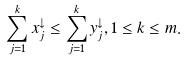Convert formula to latex. <formula><loc_0><loc_0><loc_500><loc_500>\sum _ { j = 1 } ^ { k } x _ { j } ^ { \downarrow } \leq \sum _ { j = 1 } ^ { k } y _ { j } ^ { \downarrow } , 1 \leq k \leq m .</formula> 